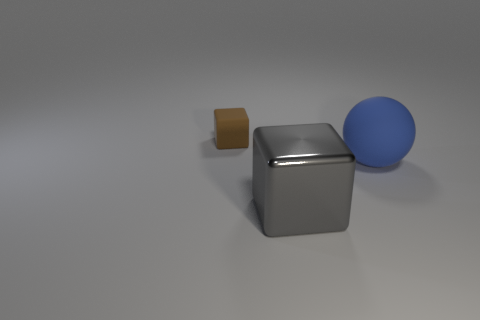The cube that is in front of the small object that is left of the large blue thing is made of what material?
Provide a succinct answer. Metal. There is a rubber thing behind the big object behind the cube right of the tiny rubber thing; how big is it?
Provide a short and direct response. Small. Do the metallic cube and the blue sphere have the same size?
Ensure brevity in your answer.  Yes. There is a thing to the left of the big gray shiny thing; is its shape the same as the large thing on the left side of the big blue object?
Offer a very short reply. Yes. Are there any cubes that are behind the rubber thing in front of the small brown thing?
Give a very brief answer. Yes. Are there any big purple things?
Your answer should be compact. No. What number of matte balls have the same size as the gray metallic thing?
Give a very brief answer. 1. How many things are to the left of the blue rubber thing and behind the big gray block?
Provide a succinct answer. 1. Is the size of the block in front of the matte block the same as the sphere?
Provide a succinct answer. Yes. What is the size of the blue thing that is made of the same material as the tiny block?
Your answer should be compact. Large. 